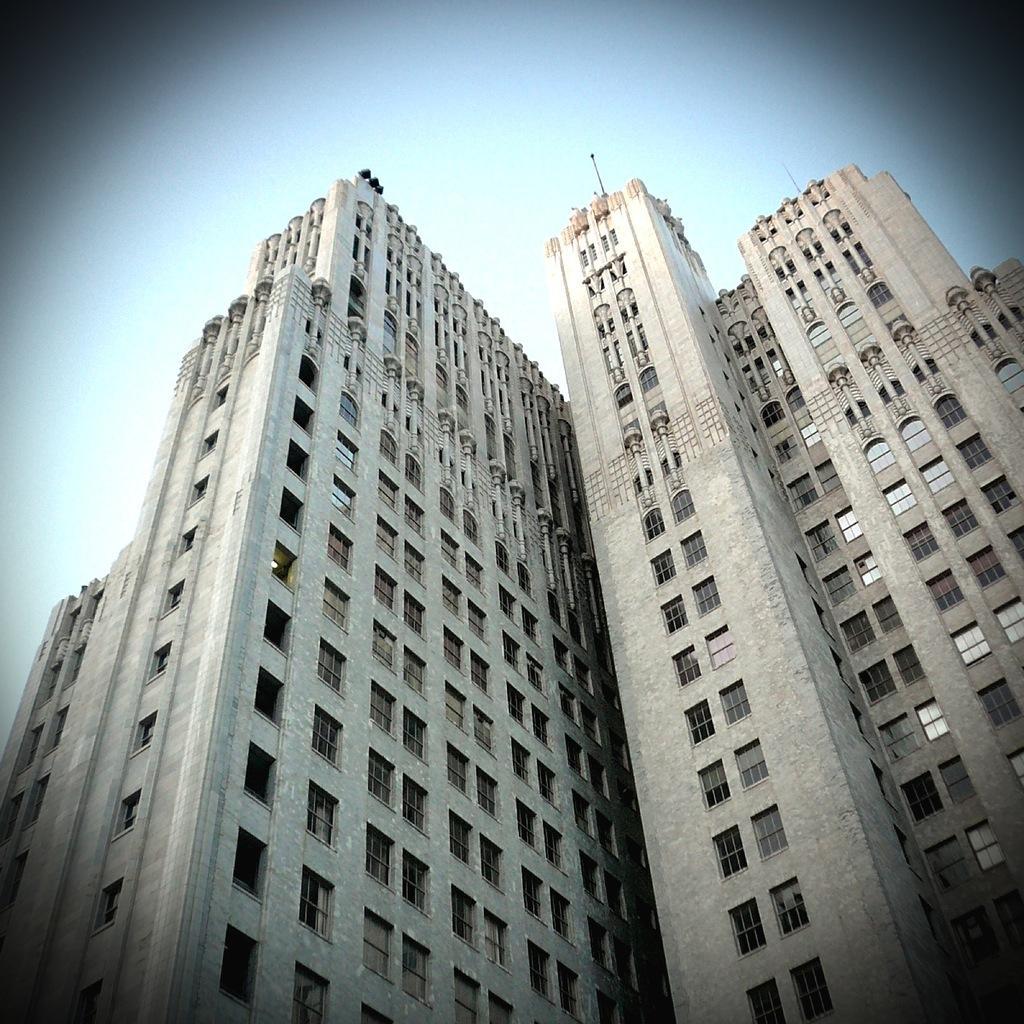Can you describe this image briefly? In this image there are buildings. In the background there is sky. 